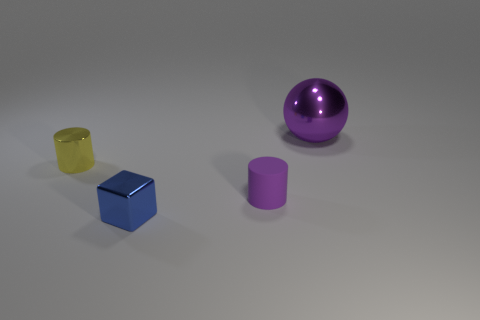Add 4 big metallic spheres. How many objects exist? 8 Subtract all yellow cylinders. How many cylinders are left? 1 Add 4 small shiny things. How many small shiny things are left? 6 Add 3 tiny blue metallic things. How many tiny blue metallic things exist? 4 Subtract 0 brown cubes. How many objects are left? 4 Subtract all cubes. How many objects are left? 3 Subtract 1 balls. How many balls are left? 0 Subtract all yellow cubes. Subtract all purple balls. How many cubes are left? 1 Subtract all brown cylinders. How many green spheres are left? 0 Subtract all brown rubber balls. Subtract all purple metal objects. How many objects are left? 3 